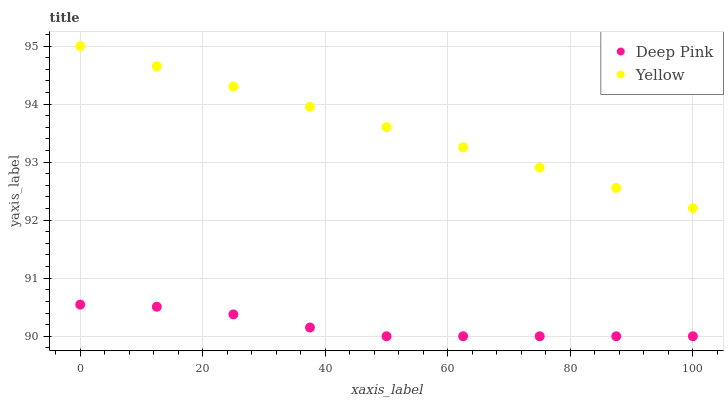Does Deep Pink have the minimum area under the curve?
Answer yes or no. Yes. Does Yellow have the maximum area under the curve?
Answer yes or no. Yes. Does Yellow have the minimum area under the curve?
Answer yes or no. No. Is Yellow the smoothest?
Answer yes or no. Yes. Is Deep Pink the roughest?
Answer yes or no. Yes. Is Yellow the roughest?
Answer yes or no. No. Does Deep Pink have the lowest value?
Answer yes or no. Yes. Does Yellow have the lowest value?
Answer yes or no. No. Does Yellow have the highest value?
Answer yes or no. Yes. Is Deep Pink less than Yellow?
Answer yes or no. Yes. Is Yellow greater than Deep Pink?
Answer yes or no. Yes. Does Deep Pink intersect Yellow?
Answer yes or no. No. 